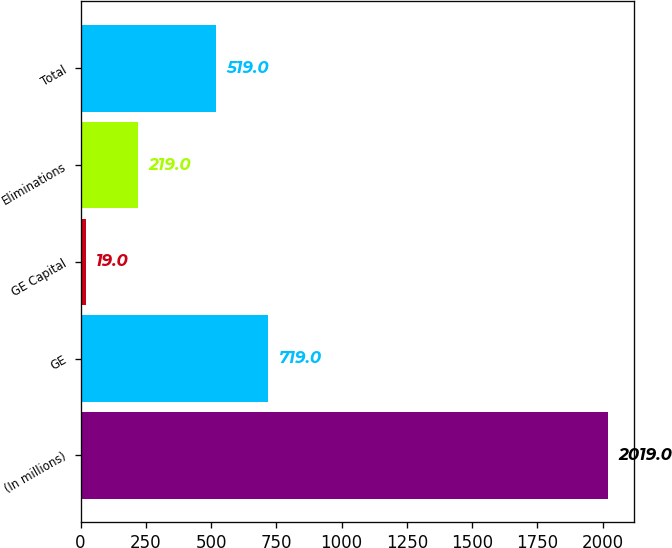Convert chart. <chart><loc_0><loc_0><loc_500><loc_500><bar_chart><fcel>(In millions)<fcel>GE<fcel>GE Capital<fcel>Eliminations<fcel>Total<nl><fcel>2019<fcel>719<fcel>19<fcel>219<fcel>519<nl></chart> 